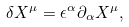Convert formula to latex. <formula><loc_0><loc_0><loc_500><loc_500>\delta X ^ { \mu } = \epsilon ^ { \alpha } \partial _ { \alpha } X ^ { \mu } ,</formula> 